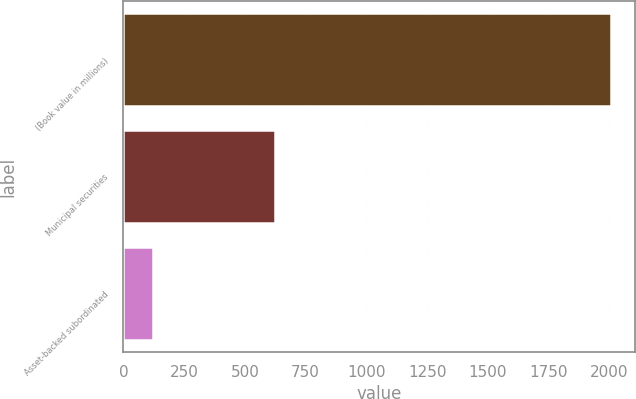Convert chart. <chart><loc_0><loc_0><loc_500><loc_500><bar_chart><fcel>(Book value in millions)<fcel>Municipal securities<fcel>Asset-backed subordinated<nl><fcel>2005<fcel>625<fcel>120<nl></chart> 